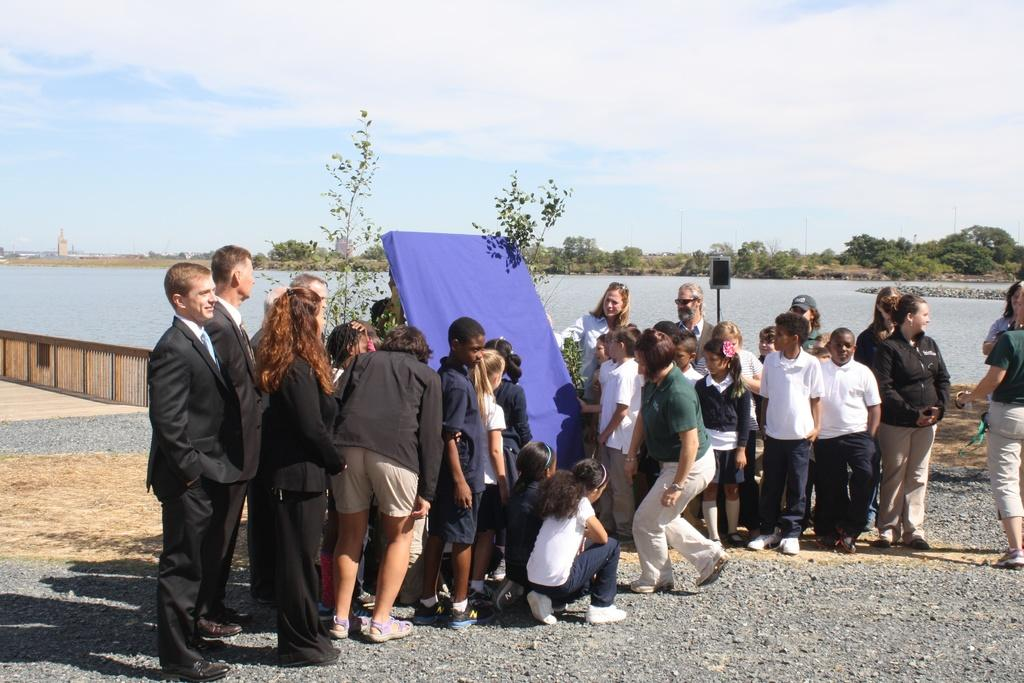How many people are present in the image? There are many people in the image. What natural feature can be seen in the image? There is a lake visible in the image. What type of vegetation is present in the image? There are many trees in the image. What is visible in the sky in the image? The sky is visible in the image, and there are clouds in the sky. What type of barrier can be seen in the image? There is a fence in the image. What type of juice can be seen in the image? There is no juice present in the image. 